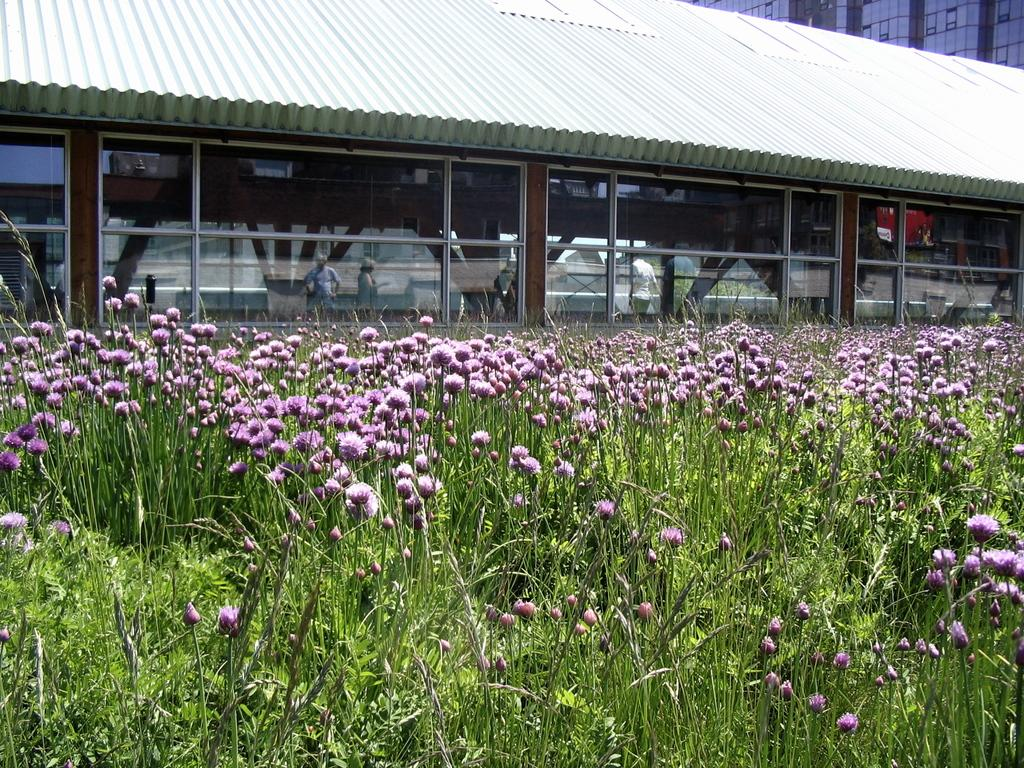What type of vegetation is in the front of the image? There are flowers in the front of the image. What else can be seen in the image besides flowers? There are plants in the image. What can be seen in the background of the image? There are buildings in the background of the image. What type of insurance is being sold at the market in the image? There is no market or insurance mentioned in the image; it features flowers, plants, and buildings. What kind of yam is being harvested in the image? There is no yam or harvesting activity present in the image. 